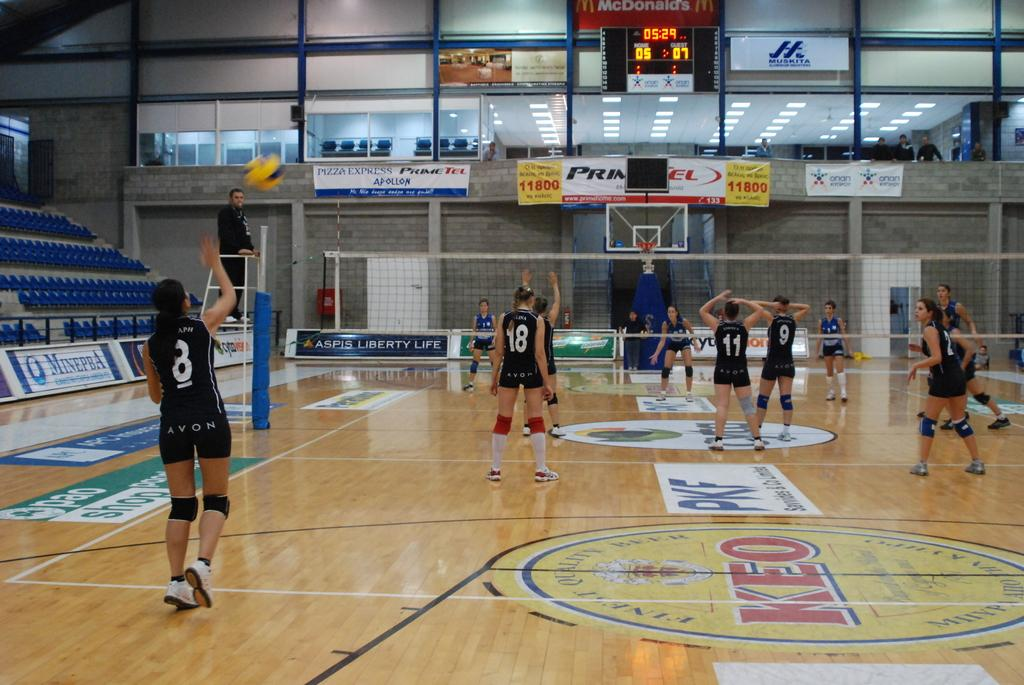Provide a one-sentence caption for the provided image. Avon basketball players 18, 11, and 9 face the hoop while player 8 takes her shot. 